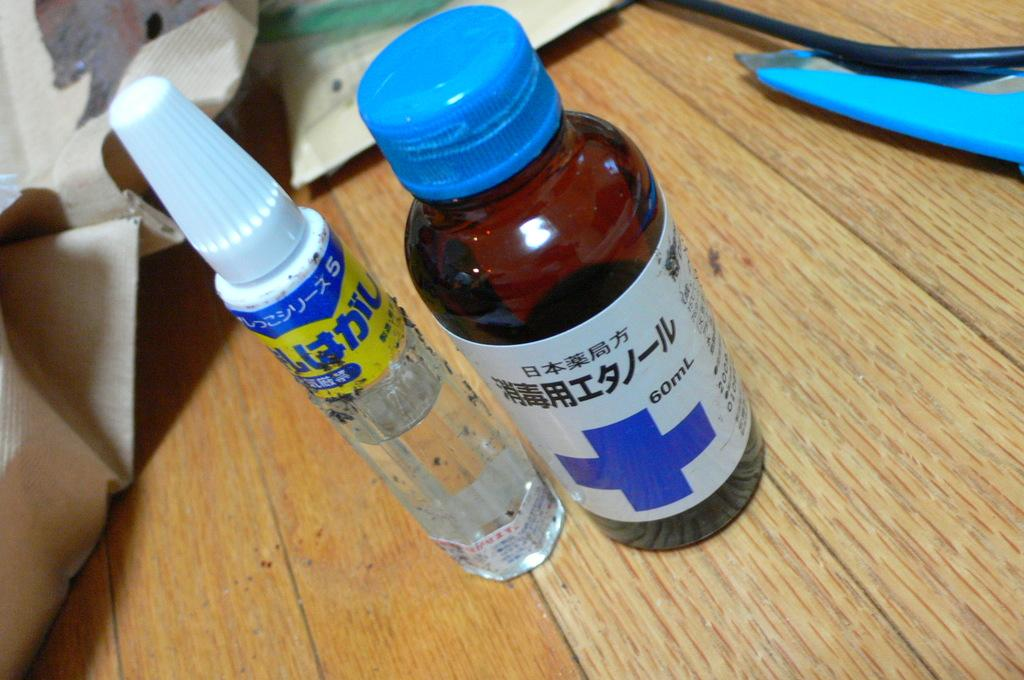<image>
Relay a brief, clear account of the picture shown. the number 60 is on the brown bottle on the table 